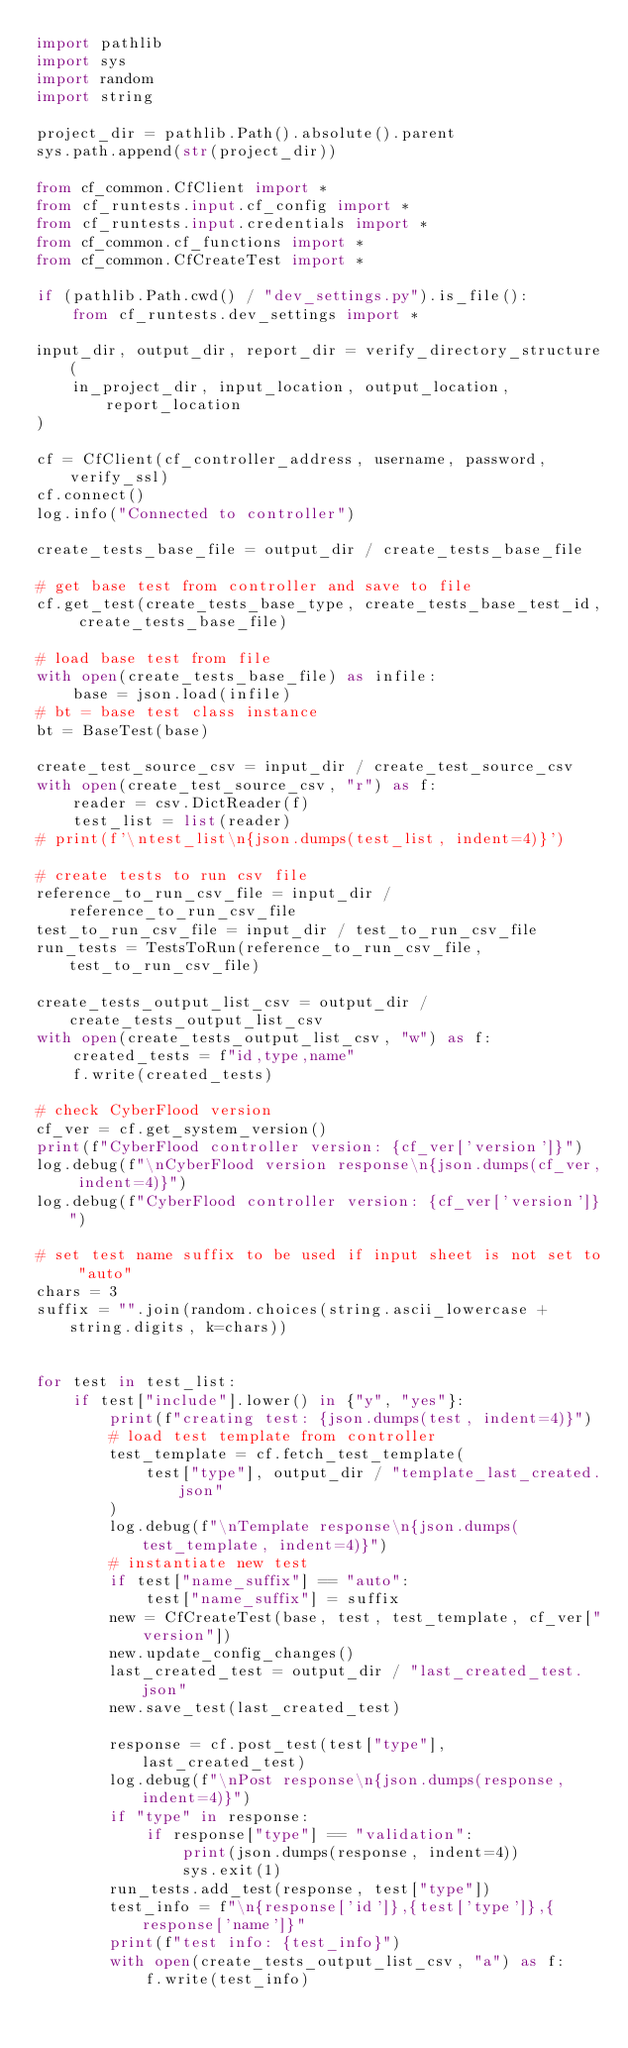Convert code to text. <code><loc_0><loc_0><loc_500><loc_500><_Python_>import pathlib
import sys
import random
import string

project_dir = pathlib.Path().absolute().parent
sys.path.append(str(project_dir))

from cf_common.CfClient import *
from cf_runtests.input.cf_config import *
from cf_runtests.input.credentials import *
from cf_common.cf_functions import *
from cf_common.CfCreateTest import *

if (pathlib.Path.cwd() / "dev_settings.py").is_file():
    from cf_runtests.dev_settings import *

input_dir, output_dir, report_dir = verify_directory_structure(
    in_project_dir, input_location, output_location, report_location
)

cf = CfClient(cf_controller_address, username, password, verify_ssl)
cf.connect()
log.info("Connected to controller")

create_tests_base_file = output_dir / create_tests_base_file

# get base test from controller and save to file
cf.get_test(create_tests_base_type, create_tests_base_test_id, create_tests_base_file)

# load base test from file
with open(create_tests_base_file) as infile:
    base = json.load(infile)
# bt = base test class instance
bt = BaseTest(base)

create_test_source_csv = input_dir / create_test_source_csv
with open(create_test_source_csv, "r") as f:
    reader = csv.DictReader(f)
    test_list = list(reader)
# print(f'\ntest_list\n{json.dumps(test_list, indent=4)}')

# create tests to run csv file
reference_to_run_csv_file = input_dir / reference_to_run_csv_file
test_to_run_csv_file = input_dir / test_to_run_csv_file
run_tests = TestsToRun(reference_to_run_csv_file, test_to_run_csv_file)

create_tests_output_list_csv = output_dir / create_tests_output_list_csv
with open(create_tests_output_list_csv, "w") as f:
    created_tests = f"id,type,name"
    f.write(created_tests)

# check CyberFlood version
cf_ver = cf.get_system_version()
print(f"CyberFlood controller version: {cf_ver['version']}")
log.debug(f"\nCyberFlood version response\n{json.dumps(cf_ver, indent=4)}")
log.debug(f"CyberFlood controller version: {cf_ver['version']}")

# set test name suffix to be used if input sheet is not set to "auto"
chars = 3
suffix = "".join(random.choices(string.ascii_lowercase + string.digits, k=chars))


for test in test_list:
    if test["include"].lower() in {"y", "yes"}:
        print(f"creating test: {json.dumps(test, indent=4)}")
        # load test template from controller
        test_template = cf.fetch_test_template(
            test["type"], output_dir / "template_last_created.json"
        )
        log.debug(f"\nTemplate response\n{json.dumps(test_template, indent=4)}")
        # instantiate new test
        if test["name_suffix"] == "auto":
            test["name_suffix"] = suffix
        new = CfCreateTest(base, test, test_template, cf_ver["version"])
        new.update_config_changes()
        last_created_test = output_dir / "last_created_test.json"
        new.save_test(last_created_test)

        response = cf.post_test(test["type"], last_created_test)
        log.debug(f"\nPost response\n{json.dumps(response, indent=4)}")
        if "type" in response:
            if response["type"] == "validation":
                print(json.dumps(response, indent=4))
                sys.exit(1)
        run_tests.add_test(response, test["type"])
        test_info = f"\n{response['id']},{test['type']},{response['name']}"
        print(f"test info: {test_info}")
        with open(create_tests_output_list_csv, "a") as f:
            f.write(test_info)
</code> 